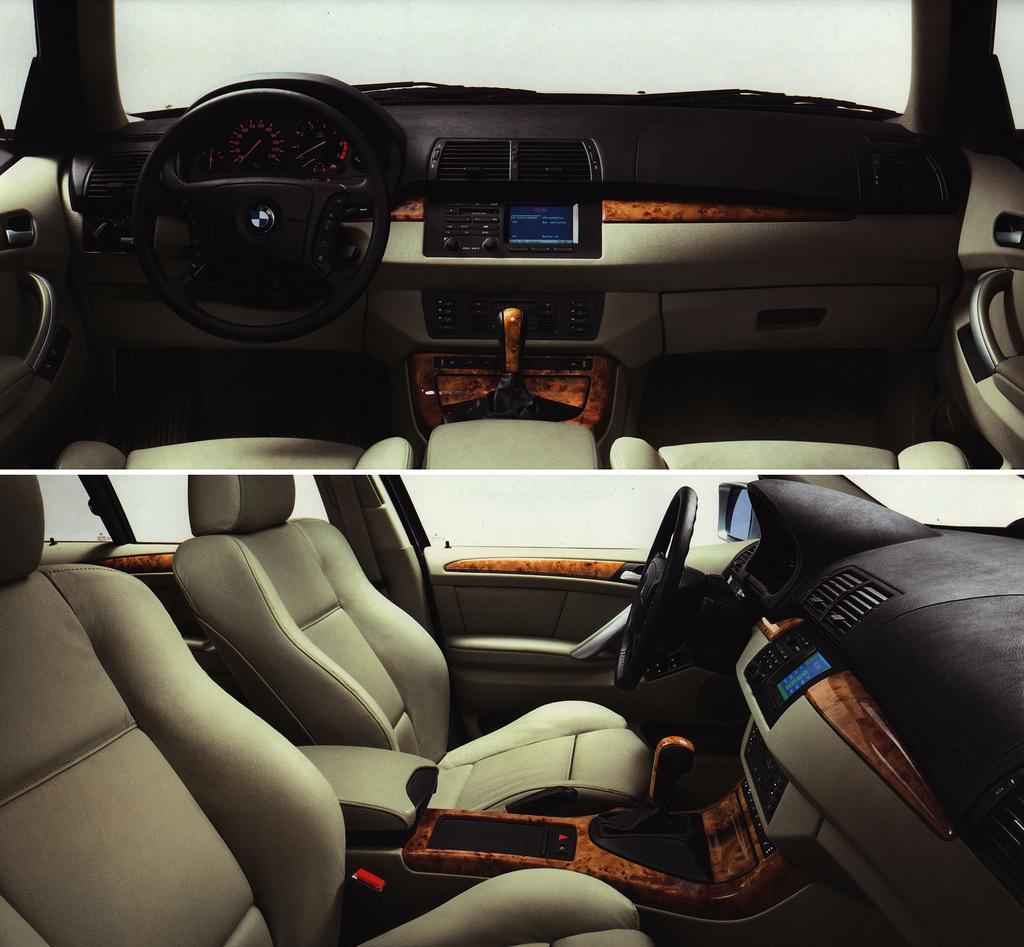Describe this image in one or two sentences. This is a collage picture. At the top there is a vehicle and there is a steering. At the bottom there are seats and there are windows and there is a mirror. 